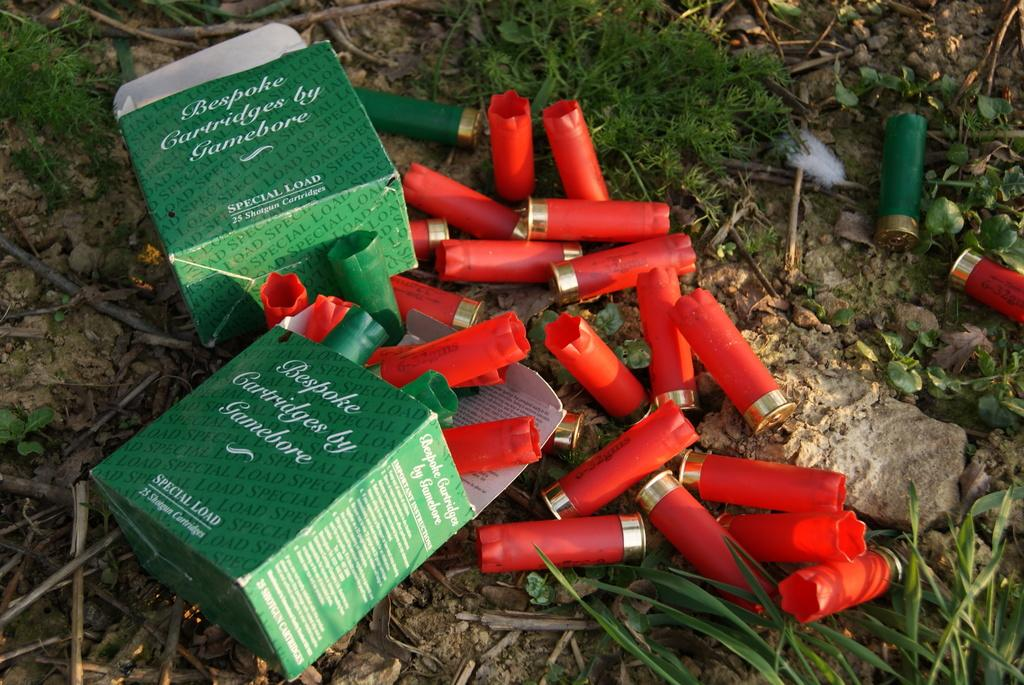How many boxes are present in the image? There are two boxes in the image. What colors can be seen among the objects on the floor? There are red and green color objects on the objects on the floor. What type of natural environment is visible in the image? There is grass visible in the image. What other objects can be seen on the floor in the image? There are rocks on the floor in the image. How does the stove increase the temperature in the image? There is no stove present in the image, so it cannot increase the temperature. 